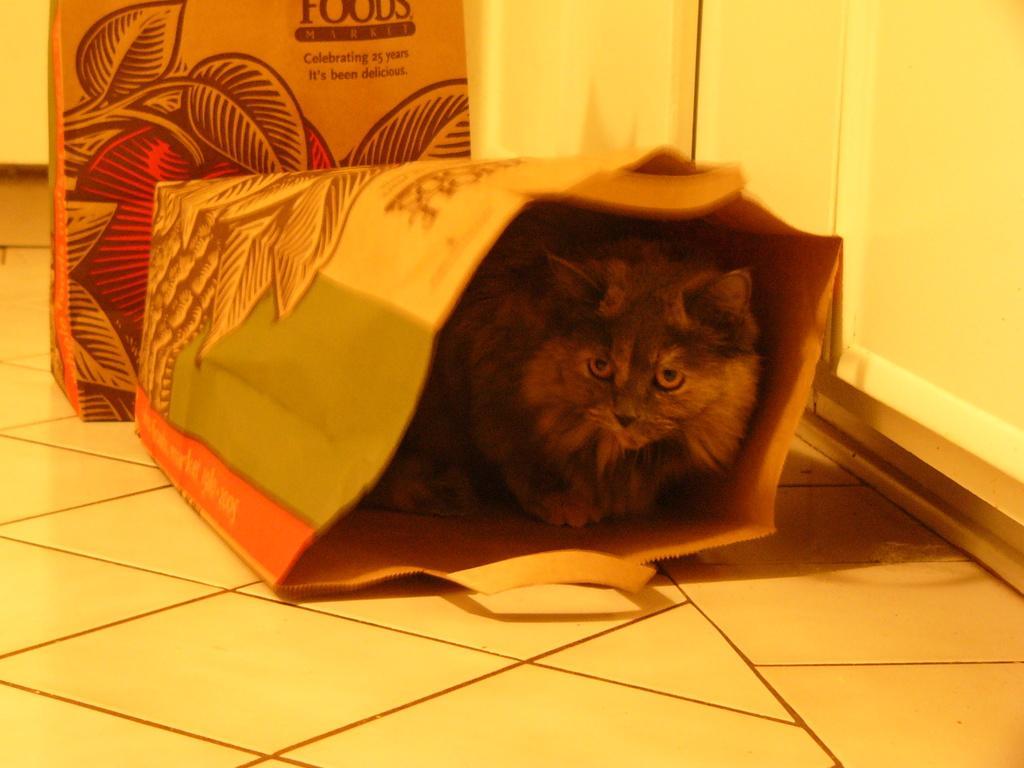Can you describe this image briefly? In the center of the image we can see cat in the bag. In the background we can see bag and wall. 